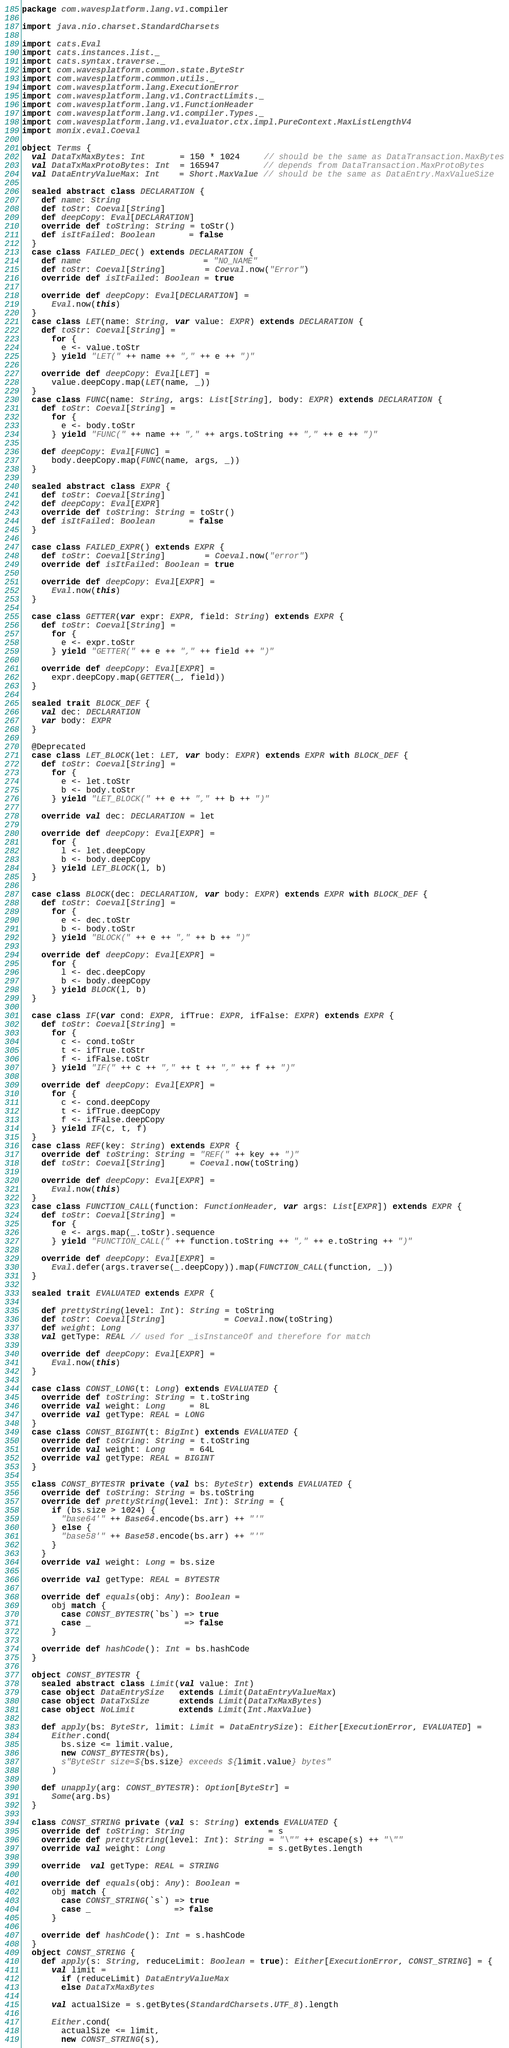Convert code to text. <code><loc_0><loc_0><loc_500><loc_500><_Scala_>package com.wavesplatform.lang.v1.compiler

import java.nio.charset.StandardCharsets

import cats.Eval
import cats.instances.list._
import cats.syntax.traverse._
import com.wavesplatform.common.state.ByteStr
import com.wavesplatform.common.utils._
import com.wavesplatform.lang.ExecutionError
import com.wavesplatform.lang.v1.ContractLimits._
import com.wavesplatform.lang.v1.FunctionHeader
import com.wavesplatform.lang.v1.compiler.Types._
import com.wavesplatform.lang.v1.evaluator.ctx.impl.PureContext.MaxListLengthV4
import monix.eval.Coeval

object Terms {
  val DataTxMaxBytes: Int       = 150 * 1024     // should be the same as DataTransaction.MaxBytes
  val DataTxMaxProtoBytes: Int  = 165947         // depends from DataTransaction.MaxProtoBytes
  val DataEntryValueMax: Int    = Short.MaxValue // should be the same as DataEntry.MaxValueSize

  sealed abstract class DECLARATION {
    def name: String
    def toStr: Coeval[String]
    def deepCopy: Eval[DECLARATION]
    override def toString: String = toStr()
    def isItFailed: Boolean       = false
  }
  case class FAILED_DEC() extends DECLARATION {
    def name                         = "NO_NAME"
    def toStr: Coeval[String]        = Coeval.now("Error")
    override def isItFailed: Boolean = true

    override def deepCopy: Eval[DECLARATION] =
      Eval.now(this)
  }
  case class LET(name: String, var value: EXPR) extends DECLARATION {
    def toStr: Coeval[String] =
      for {
        e <- value.toStr
      } yield "LET(" ++ name ++ "," ++ e ++ ")"

    override def deepCopy: Eval[LET] =
      value.deepCopy.map(LET(name, _))
  }
  case class FUNC(name: String, args: List[String], body: EXPR) extends DECLARATION {
    def toStr: Coeval[String] =
      for {
        e <- body.toStr
      } yield "FUNC(" ++ name ++ "," ++ args.toString ++ "," ++ e ++ ")"

    def deepCopy: Eval[FUNC] =
      body.deepCopy.map(FUNC(name, args, _))
  }

  sealed abstract class EXPR {
    def toStr: Coeval[String]
    def deepCopy: Eval[EXPR]
    override def toString: String = toStr()
    def isItFailed: Boolean       = false
  }

  case class FAILED_EXPR() extends EXPR {
    def toStr: Coeval[String]        = Coeval.now("error")
    override def isItFailed: Boolean = true

    override def deepCopy: Eval[EXPR] =
      Eval.now(this)
  }

  case class GETTER(var expr: EXPR, field: String) extends EXPR {
    def toStr: Coeval[String] =
      for {
        e <- expr.toStr
      } yield "GETTER(" ++ e ++ "," ++ field ++ ")"

    override def deepCopy: Eval[EXPR] =
      expr.deepCopy.map(GETTER(_, field))
  }

  sealed trait BLOCK_DEF {
    val dec: DECLARATION
    var body: EXPR
  }

  @Deprecated
  case class LET_BLOCK(let: LET, var body: EXPR) extends EXPR with BLOCK_DEF {
    def toStr: Coeval[String] =
      for {
        e <- let.toStr
        b <- body.toStr
      } yield "LET_BLOCK(" ++ e ++ "," ++ b ++ ")"

    override val dec: DECLARATION = let

    override def deepCopy: Eval[EXPR] =
      for {
        l <- let.deepCopy
        b <- body.deepCopy
      } yield LET_BLOCK(l, b)
  }

  case class BLOCK(dec: DECLARATION, var body: EXPR) extends EXPR with BLOCK_DEF {
    def toStr: Coeval[String] =
      for {
        e <- dec.toStr
        b <- body.toStr
      } yield "BLOCK(" ++ e ++ "," ++ b ++ ")"

    override def deepCopy: Eval[EXPR] =
      for {
        l <- dec.deepCopy
        b <- body.deepCopy
      } yield BLOCK(l, b)
  }

  case class IF(var cond: EXPR, ifTrue: EXPR, ifFalse: EXPR) extends EXPR {
    def toStr: Coeval[String] =
      for {
        c <- cond.toStr
        t <- ifTrue.toStr
        f <- ifFalse.toStr
      } yield "IF(" ++ c ++ "," ++ t ++ "," ++ f ++ ")"

    override def deepCopy: Eval[EXPR] =
      for {
        c <- cond.deepCopy
        t <- ifTrue.deepCopy
        f <- ifFalse.deepCopy
      } yield IF(c, t, f)
  }
  case class REF(key: String) extends EXPR {
    override def toString: String = "REF(" ++ key ++ ")"
    def toStr: Coeval[String]     = Coeval.now(toString)

    override def deepCopy: Eval[EXPR] =
      Eval.now(this)
  }
  case class FUNCTION_CALL(function: FunctionHeader, var args: List[EXPR]) extends EXPR {
    def toStr: Coeval[String] =
      for {
        e <- args.map(_.toStr).sequence
      } yield "FUNCTION_CALL(" ++ function.toString ++ "," ++ e.toString ++ ")"

    override def deepCopy: Eval[EXPR] =
      Eval.defer(args.traverse(_.deepCopy)).map(FUNCTION_CALL(function, _))
  }

  sealed trait EVALUATED extends EXPR {

    def prettyString(level: Int): String = toString
    def toStr: Coeval[String]            = Coeval.now(toString)
    def weight: Long
    val getType: REAL // used for _isInstanceOf and therefore for match

    override def deepCopy: Eval[EXPR] =
      Eval.now(this)
  }

  case class CONST_LONG(t: Long) extends EVALUATED {
    override def toString: String = t.toString
    override val weight: Long     = 8L
    override val getType: REAL = LONG
  }
  case class CONST_BIGINT(t: BigInt) extends EVALUATED {
    override def toString: String = t.toString
    override val weight: Long     = 64L
    override val getType: REAL = BIGINT
  }

  class CONST_BYTESTR private (val bs: ByteStr) extends EVALUATED {
    override def toString: String = bs.toString
    override def prettyString(level: Int): String = {
      if (bs.size > 1024) {
        "base64'" ++ Base64.encode(bs.arr) ++ "'"
      } else {
        "base58'" ++ Base58.encode(bs.arr) ++ "'"
      }
    }
    override val weight: Long = bs.size

    override val getType: REAL = BYTESTR

    override def equals(obj: Any): Boolean =
      obj match {
        case CONST_BYTESTR(`bs`) => true
        case _                   => false
      }

    override def hashCode(): Int = bs.hashCode
  }

  object CONST_BYTESTR {
    sealed abstract class Limit(val value: Int)
    case object DataEntrySize   extends Limit(DataEntryValueMax)
    case object DataTxSize      extends Limit(DataTxMaxBytes)
    case object NoLimit         extends Limit(Int.MaxValue)

    def apply(bs: ByteStr, limit: Limit = DataEntrySize): Either[ExecutionError, EVALUATED] =
      Either.cond(
        bs.size <= limit.value,
        new CONST_BYTESTR(bs),
        s"ByteStr size=${bs.size} exceeds ${limit.value} bytes"
      )

    def unapply(arg: CONST_BYTESTR): Option[ByteStr] =
      Some(arg.bs)
  }

  class CONST_STRING private (val s: String) extends EVALUATED {
    override def toString: String                 = s
    override def prettyString(level: Int): String = "\"" ++ escape(s) ++ "\""
    override val weight: Long                     = s.getBytes.length

    override  val getType: REAL = STRING

    override def equals(obj: Any): Boolean =
      obj match {
        case CONST_STRING(`s`) => true
        case _                 => false
      }

    override def hashCode(): Int = s.hashCode
  }
  object CONST_STRING {
    def apply(s: String, reduceLimit: Boolean = true): Either[ExecutionError, CONST_STRING] = {
      val limit =
        if (reduceLimit) DataEntryValueMax
        else DataTxMaxBytes

      val actualSize = s.getBytes(StandardCharsets.UTF_8).length

      Either.cond(
        actualSize <= limit,
        new CONST_STRING(s),</code> 